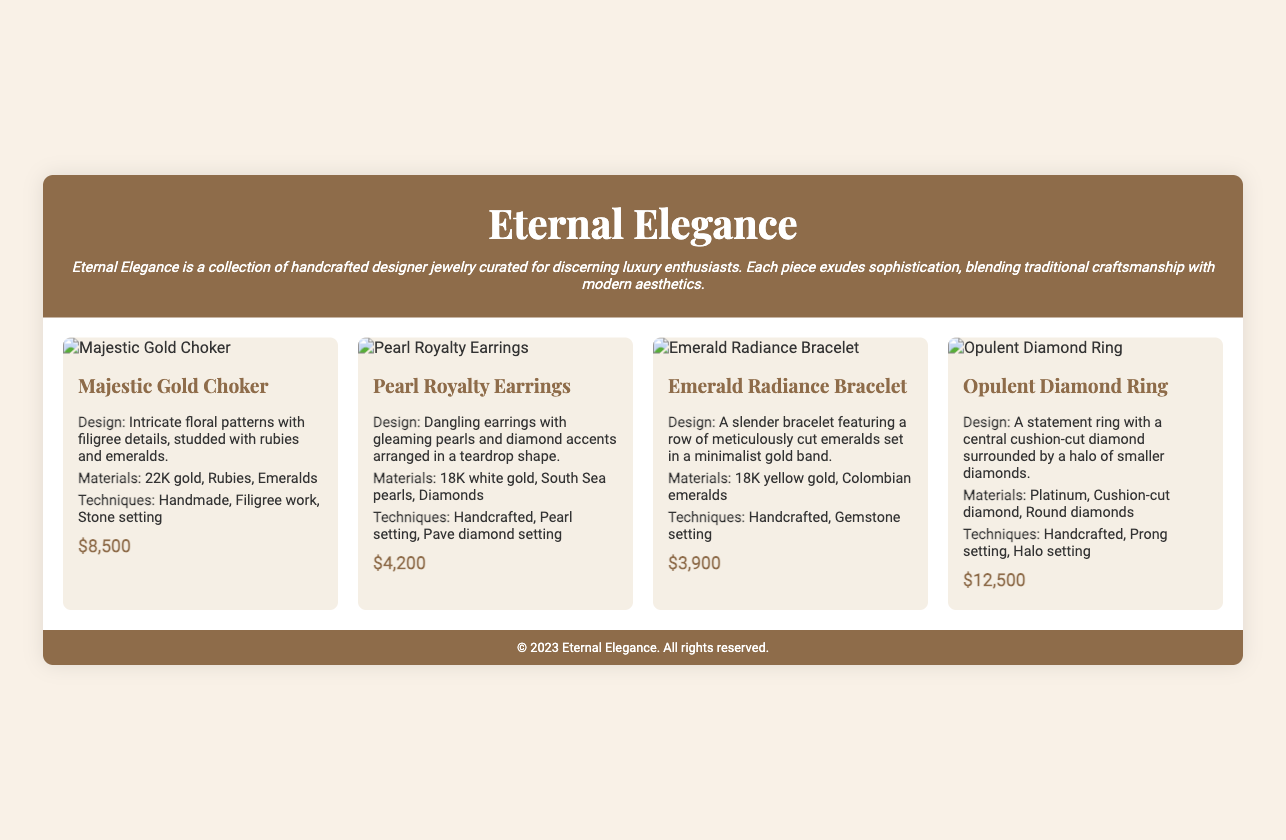What is the name of the jewelry collection? The title of the collection is mentioned in the header of the document.
Answer: Eternal Elegance How many pieces are showcased in the collection? The document features four distinct jewelry pieces in the grid layout.
Answer: 4 What is the price of the Opulent Diamond Ring? The price is clearly listed under the details of the Opulent Diamond Ring.
Answer: $12,500 What materials are used in the Pearl Royalty Earrings? The materials are specified in the description of the Pearl Royalty Earrings.
Answer: 18K white gold, South Sea pearls, Diamonds What craftsmanship technique is used for the Emerald Radiance Bracelet? The document lists the craftsmanship techniques for the Emerald Radiance Bracelet.
Answer: Handcrafted, Gemstone setting Which piece features rubies and emeralds? The description of the Majestic Gold Choker specifies the presence of these gemstones.
Answer: Majestic Gold Choker What design elements are highlighted in the Pearl Royalty Earrings? The design elements are outlined in the description of the Pearl Royalty Earrings.
Answer: Dangling earrings with gleaming pearls and diamond accents arranged in a teardrop shape What is the central gemstone in the Opulent Diamond Ring? The document specifies the type of the central gemstone in the ring.
Answer: Cushion-cut diamond What finish is the Majestic Gold Choker made of? The document mentions the type of gold in the details for Majestic Gold Choker.
Answer: 22K gold 